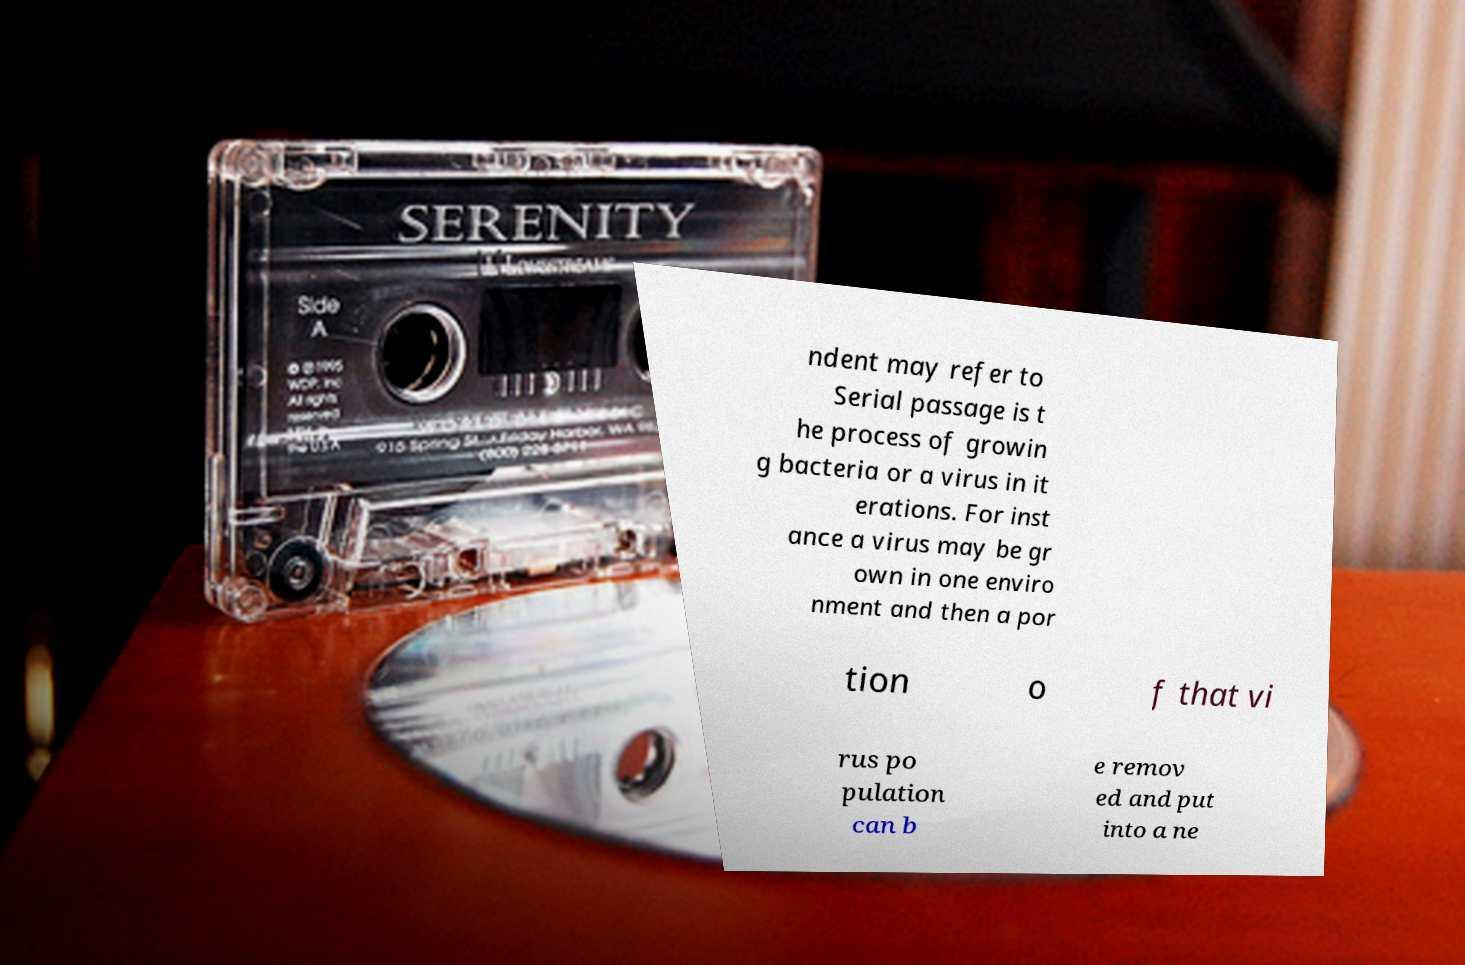Could you assist in decoding the text presented in this image and type it out clearly? ndent may refer to Serial passage is t he process of growin g bacteria or a virus in it erations. For inst ance a virus may be gr own in one enviro nment and then a por tion o f that vi rus po pulation can b e remov ed and put into a ne 